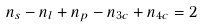<formula> <loc_0><loc_0><loc_500><loc_500>n _ { s } - n _ { l } + n _ { p } - n _ { 3 c } + n _ { 4 c } = 2</formula> 